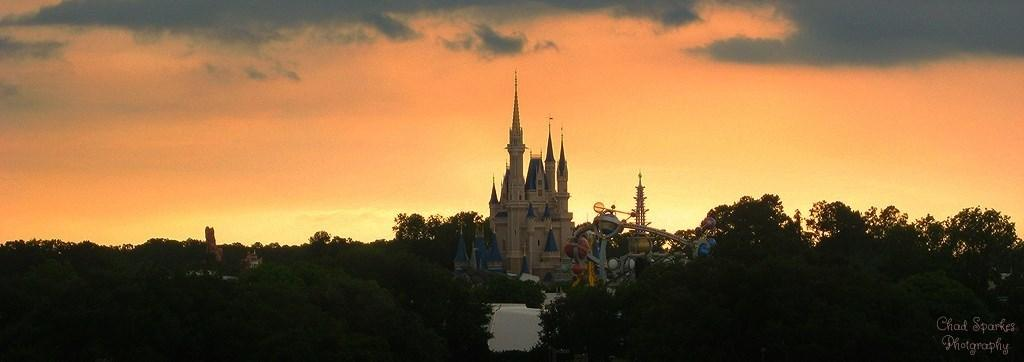What is the main structure in the center of the image? There is a building in the center of the image. What type of attraction can be seen in the image? There is a fun ride in the image. What can be seen in the background of the image? There are trees and the sky visible in the background of the image. What type of breakfast is being served at the fun ride in the image? There is no breakfast or food being served in the image; it only features a building and a fun ride. 